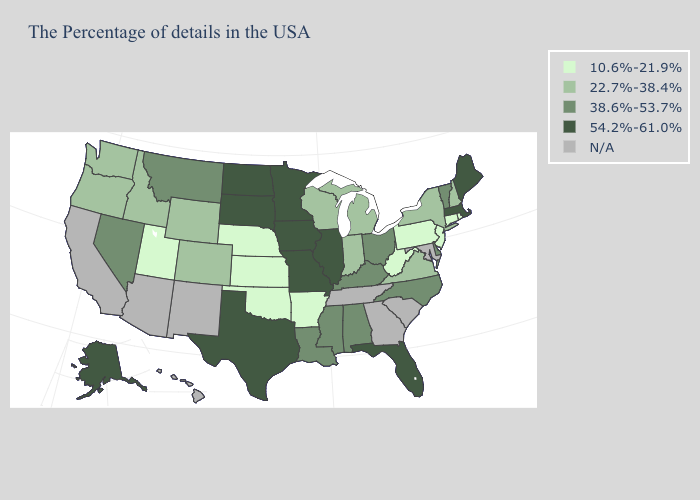Name the states that have a value in the range 10.6%-21.9%?
Be succinct. Rhode Island, Connecticut, New Jersey, Pennsylvania, West Virginia, Arkansas, Kansas, Nebraska, Oklahoma, Utah. Name the states that have a value in the range 22.7%-38.4%?
Give a very brief answer. New Hampshire, New York, Virginia, Michigan, Indiana, Wisconsin, Wyoming, Colorado, Idaho, Washington, Oregon. Does West Virginia have the lowest value in the South?
Concise answer only. Yes. What is the lowest value in the USA?
Write a very short answer. 10.6%-21.9%. Name the states that have a value in the range N/A?
Keep it brief. Maryland, South Carolina, Georgia, Tennessee, New Mexico, Arizona, California, Hawaii. Name the states that have a value in the range 54.2%-61.0%?
Keep it brief. Maine, Massachusetts, Florida, Illinois, Missouri, Minnesota, Iowa, Texas, South Dakota, North Dakota, Alaska. Name the states that have a value in the range 54.2%-61.0%?
Concise answer only. Maine, Massachusetts, Florida, Illinois, Missouri, Minnesota, Iowa, Texas, South Dakota, North Dakota, Alaska. Name the states that have a value in the range 38.6%-53.7%?
Write a very short answer. Vermont, Delaware, North Carolina, Ohio, Kentucky, Alabama, Mississippi, Louisiana, Montana, Nevada. What is the value of Vermont?
Be succinct. 38.6%-53.7%. Does Michigan have the highest value in the USA?
Keep it brief. No. What is the value of Utah?
Concise answer only. 10.6%-21.9%. Does Wisconsin have the highest value in the MidWest?
Quick response, please. No. Name the states that have a value in the range N/A?
Be succinct. Maryland, South Carolina, Georgia, Tennessee, New Mexico, Arizona, California, Hawaii. What is the value of North Carolina?
Give a very brief answer. 38.6%-53.7%. 